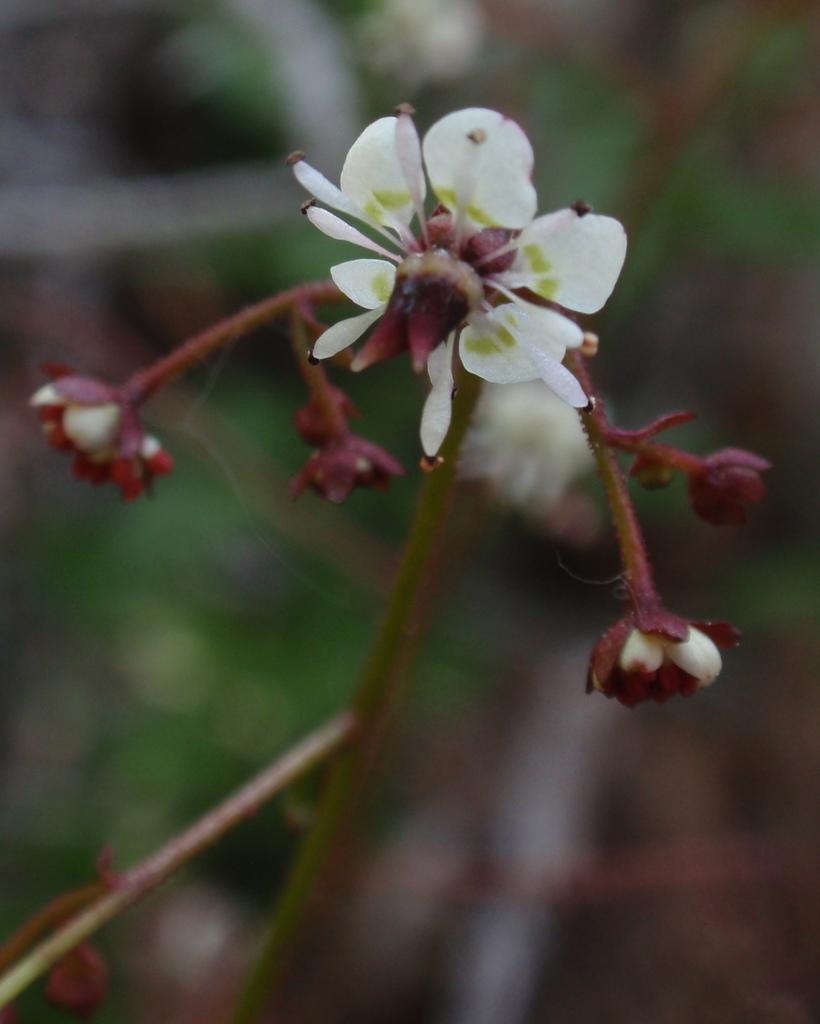What type of living organisms can be seen in the image? There are flowers and buds in the image. Are the flowers and buds part of a larger organism? Yes, the flowers and buds are part of a plant. What can be observed about the background of the image? The background of the image is blurry. What type of event is the woman wearing a suit attending in the image? There is no woman or suit present in the image; it only features flowers, buds, and a plant. 